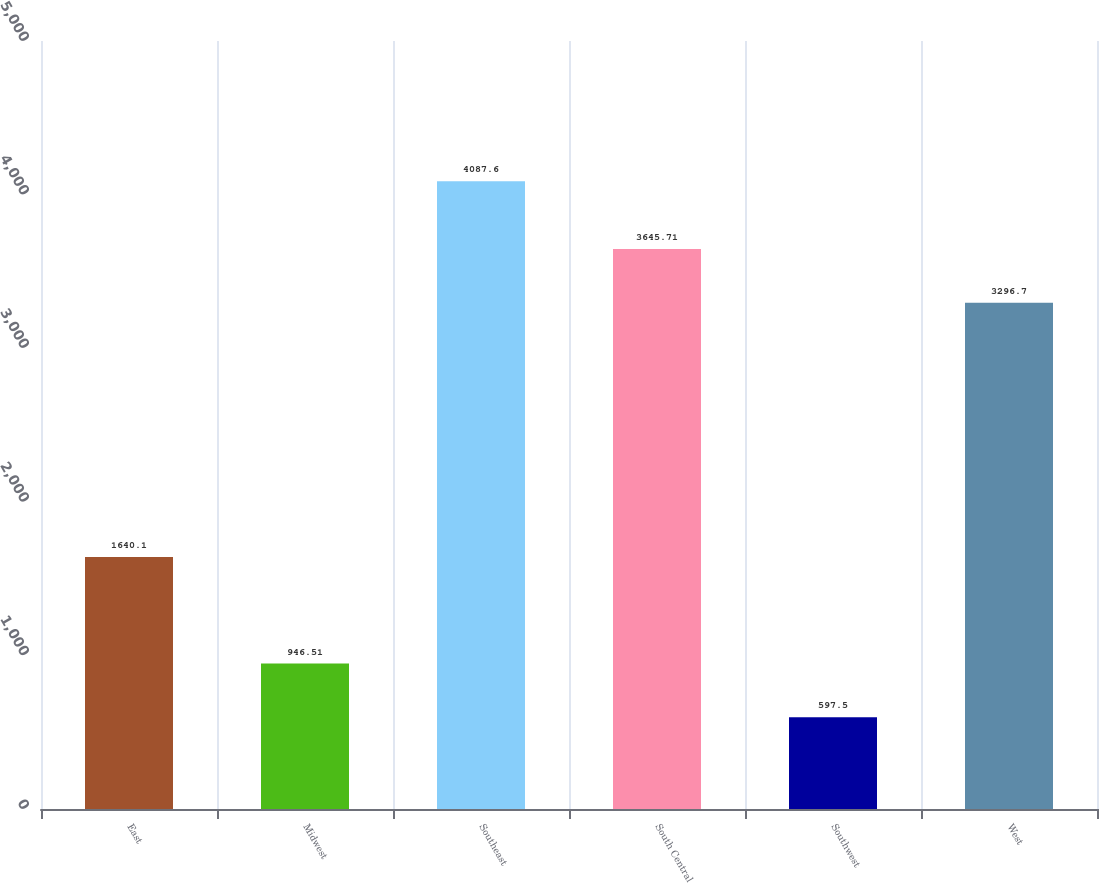Convert chart to OTSL. <chart><loc_0><loc_0><loc_500><loc_500><bar_chart><fcel>East<fcel>Midwest<fcel>Southeast<fcel>South Central<fcel>Southwest<fcel>West<nl><fcel>1640.1<fcel>946.51<fcel>4087.6<fcel>3645.71<fcel>597.5<fcel>3296.7<nl></chart> 